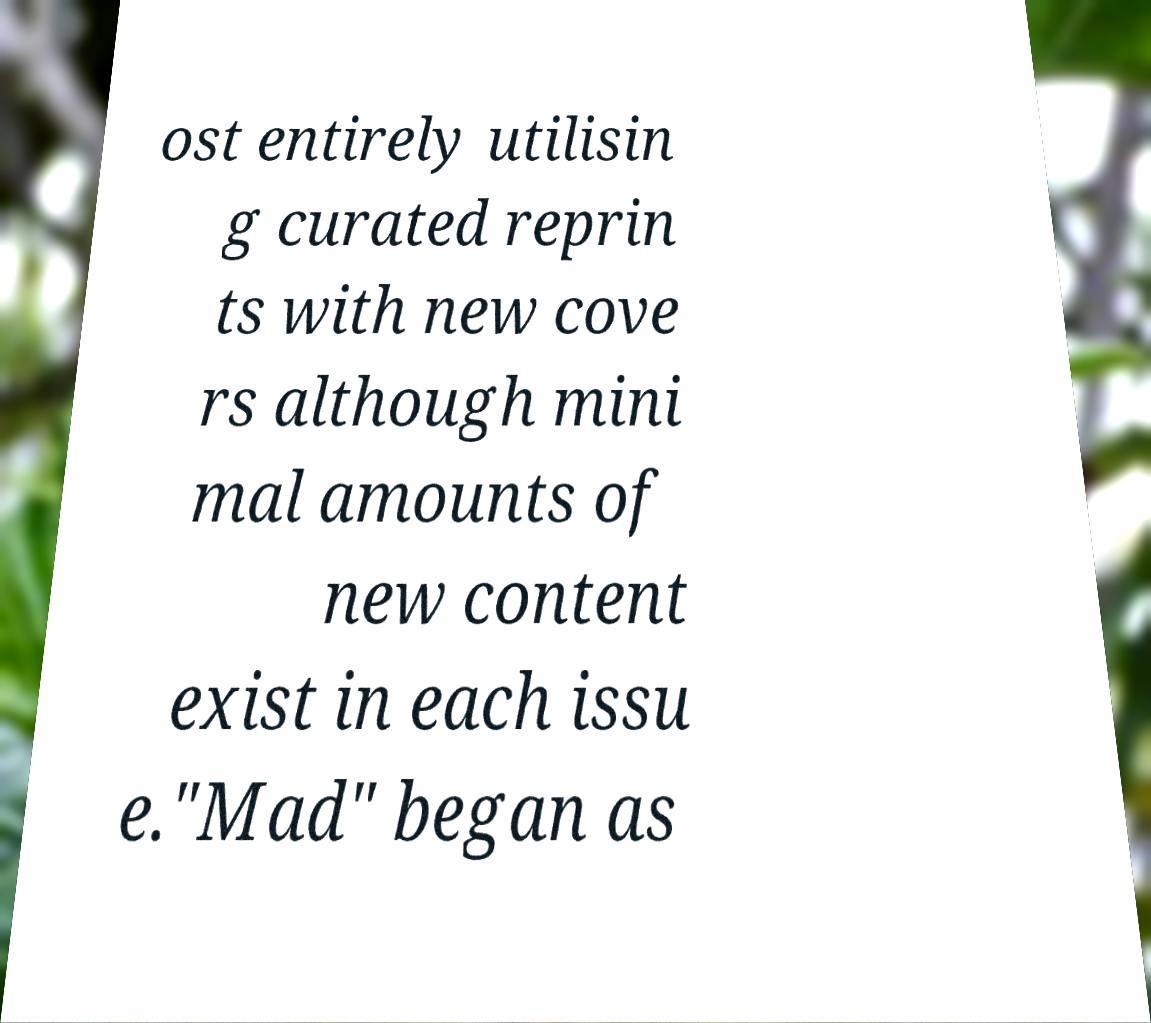Could you assist in decoding the text presented in this image and type it out clearly? ost entirely utilisin g curated reprin ts with new cove rs although mini mal amounts of new content exist in each issu e."Mad" began as 